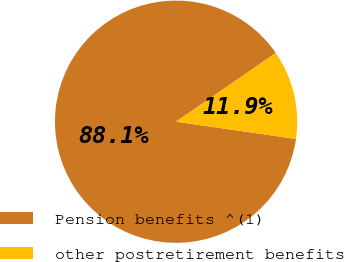Convert chart to OTSL. <chart><loc_0><loc_0><loc_500><loc_500><pie_chart><fcel>Pension benefits ^(1)<fcel>other postretirement benefits<nl><fcel>88.12%<fcel>11.88%<nl></chart> 